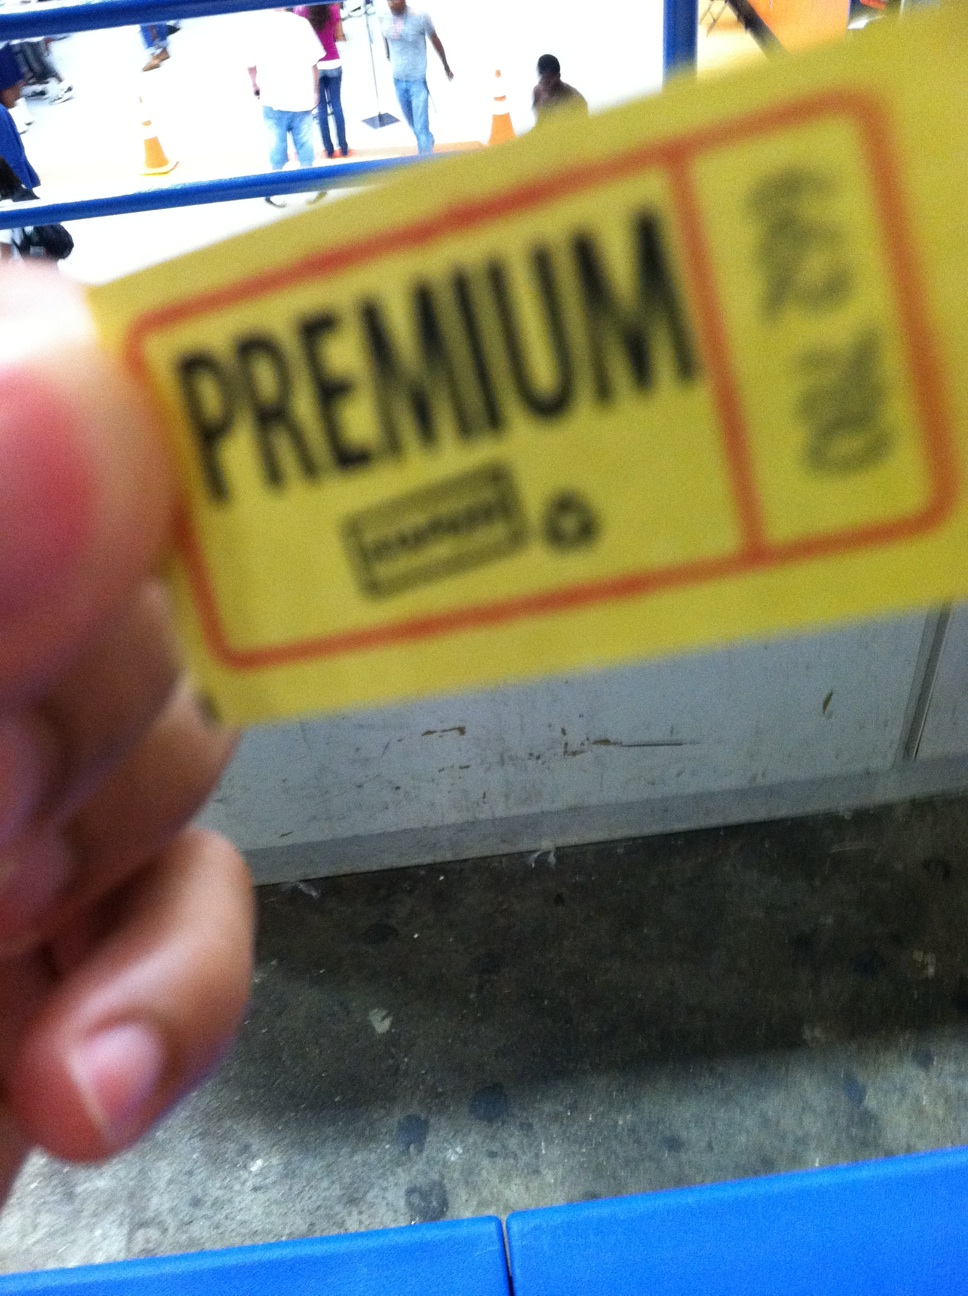Can you tell me more about what's on the card? The card in the image is yellow with the word 'PREMIUM' printed in bold letters. It's difficult to discern further details due to the blurred focus, but it could be a kind of pass or voucher, possibly for an event or service. 